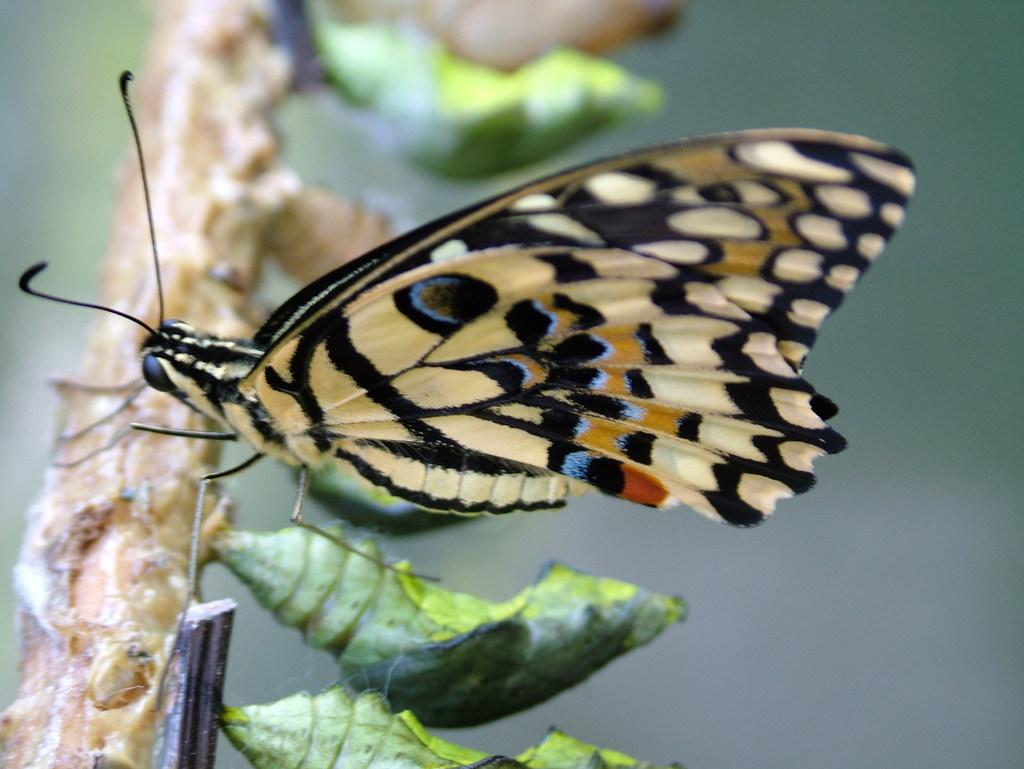What type of insect can be seen in the image? There is a butterfly in the image. What stage of development are some of the insects in the image? There are cocoons in the image, which represent the stage before a butterfly emerges. Where are the butterfly and cocoons located in the image? The butterfly and cocoons are on the branch of a tree. What type of mitten is being worn by the men in the image? There are no men or mittens present in the image; it features a butterfly and cocoons on a tree branch. 